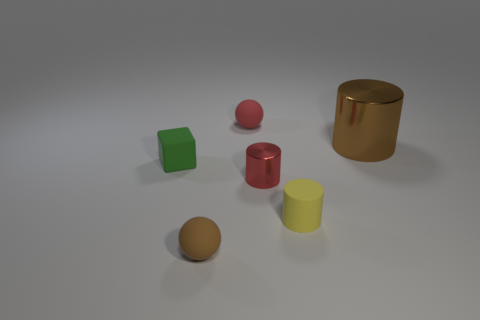Add 2 green matte cubes. How many objects exist? 8 Subtract all blocks. How many objects are left? 5 Add 4 large brown metallic objects. How many large brown metallic objects are left? 5 Add 3 red rubber balls. How many red rubber balls exist? 4 Subtract 0 purple cylinders. How many objects are left? 6 Subtract all green cylinders. Subtract all green objects. How many objects are left? 5 